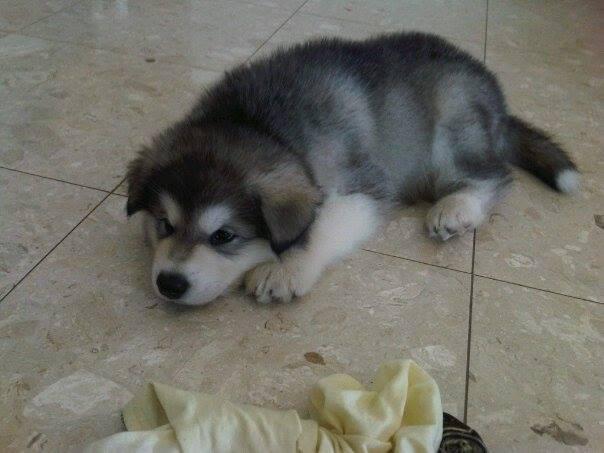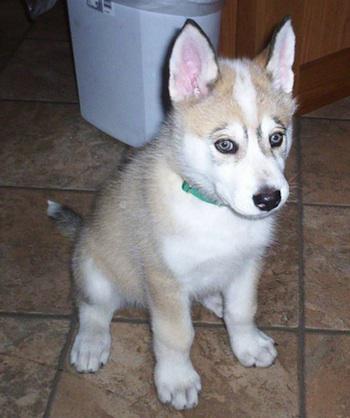The first image is the image on the left, the second image is the image on the right. Evaluate the accuracy of this statement regarding the images: "All dogs are young husky puppies, the combined images include at least two black-and-white puppies, and one image shows a pair of puppies with all floppy ears, posed side-by-side and facing the camera.". Is it true? Answer yes or no. No. The first image is the image on the left, the second image is the image on the right. Evaluate the accuracy of this statement regarding the images: "There are three dogs". Is it true? Answer yes or no. No. 